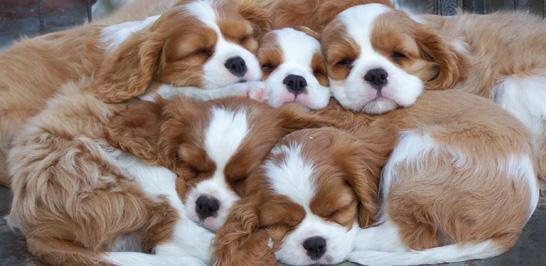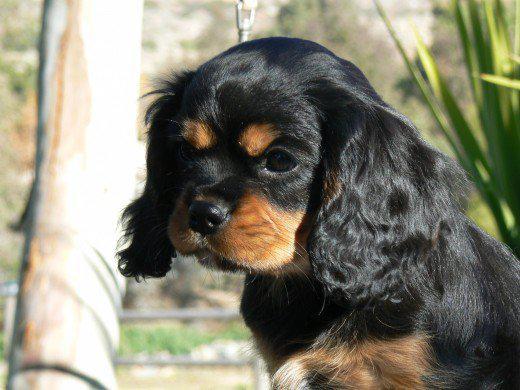The first image is the image on the left, the second image is the image on the right. For the images displayed, is the sentence "There are more dogs in the right-hand image than the left." factually correct? Answer yes or no. No. 